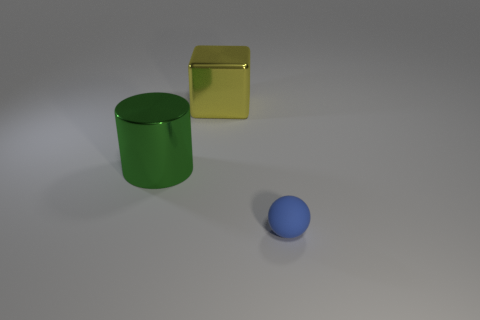Add 3 small things. How many objects exist? 6 Subtract all blocks. How many objects are left? 2 Subtract 0 gray cylinders. How many objects are left? 3 Subtract all blue metal cylinders. Subtract all large metallic cylinders. How many objects are left? 2 Add 2 shiny objects. How many shiny objects are left? 4 Add 1 large yellow metallic objects. How many large yellow metallic objects exist? 2 